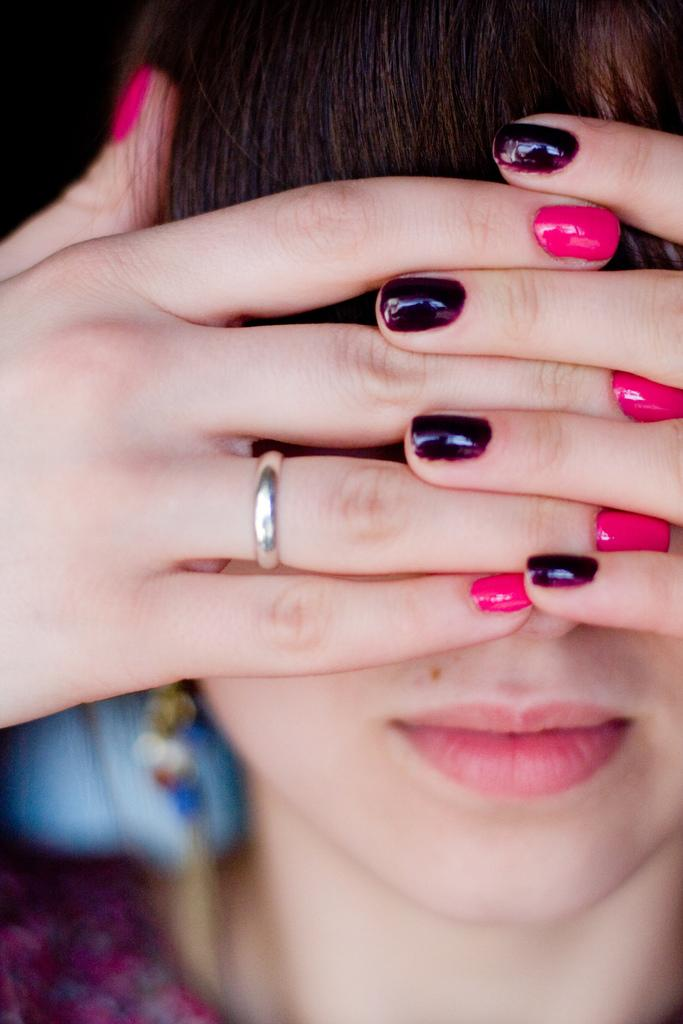Who is present in the image? There is a woman in the image. What is the woman wearing on her finger? The woman is wearing a ring on her finger. What color is the cream on the table in the image? There is no table or cream present in the image; it only features a woman wearing a ring. 